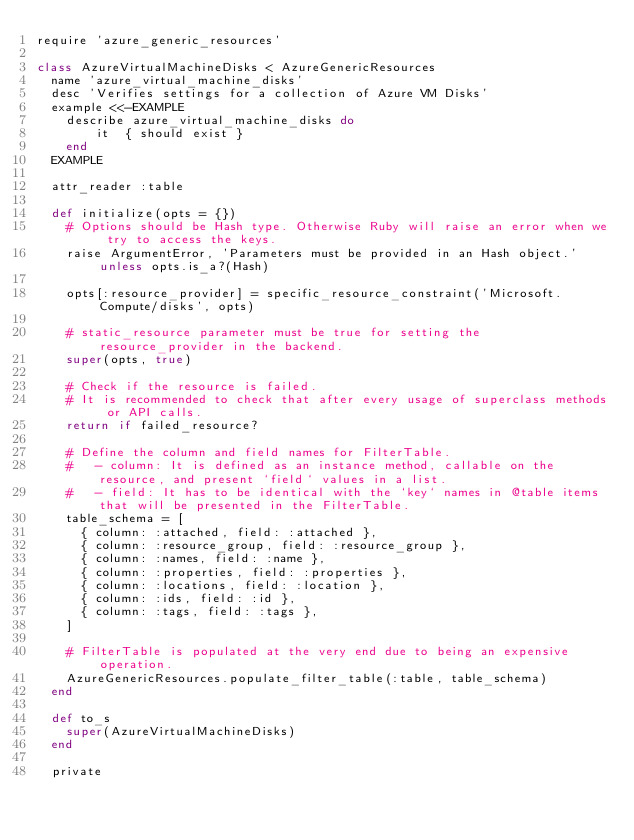Convert code to text. <code><loc_0><loc_0><loc_500><loc_500><_Ruby_>require 'azure_generic_resources'

class AzureVirtualMachineDisks < AzureGenericResources
  name 'azure_virtual_machine_disks'
  desc 'Verifies settings for a collection of Azure VM Disks'
  example <<-EXAMPLE
    describe azure_virtual_machine_disks do
        it  { should exist }
    end
  EXAMPLE

  attr_reader :table

  def initialize(opts = {})
    # Options should be Hash type. Otherwise Ruby will raise an error when we try to access the keys.
    raise ArgumentError, 'Parameters must be provided in an Hash object.' unless opts.is_a?(Hash)

    opts[:resource_provider] = specific_resource_constraint('Microsoft.Compute/disks', opts)

    # static_resource parameter must be true for setting the resource_provider in the backend.
    super(opts, true)

    # Check if the resource is failed.
    # It is recommended to check that after every usage of superclass methods or API calls.
    return if failed_resource?

    # Define the column and field names for FilterTable.
    #   - column: It is defined as an instance method, callable on the resource, and present `field` values in a list.
    #   - field: It has to be identical with the `key` names in @table items that will be presented in the FilterTable.
    table_schema = [
      { column: :attached, field: :attached },
      { column: :resource_group, field: :resource_group },
      { column: :names, field: :name },
      { column: :properties, field: :properties },
      { column: :locations, field: :location },
      { column: :ids, field: :id },
      { column: :tags, field: :tags },
    ]

    # FilterTable is populated at the very end due to being an expensive operation.
    AzureGenericResources.populate_filter_table(:table, table_schema)
  end

  def to_s
    super(AzureVirtualMachineDisks)
  end

  private
</code> 